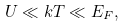<formula> <loc_0><loc_0><loc_500><loc_500>U \ll k T \ll E _ { F } ,</formula> 